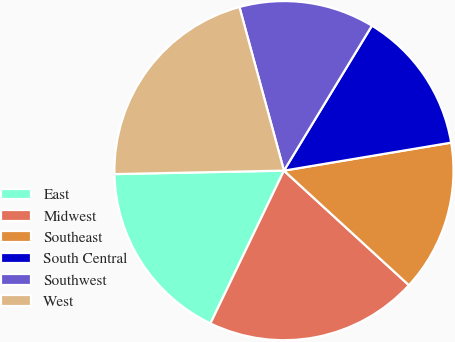Convert chart to OTSL. <chart><loc_0><loc_0><loc_500><loc_500><pie_chart><fcel>East<fcel>Midwest<fcel>Southeast<fcel>South Central<fcel>Southwest<fcel>West<nl><fcel>17.54%<fcel>20.33%<fcel>14.45%<fcel>13.68%<fcel>12.91%<fcel>21.1%<nl></chart> 